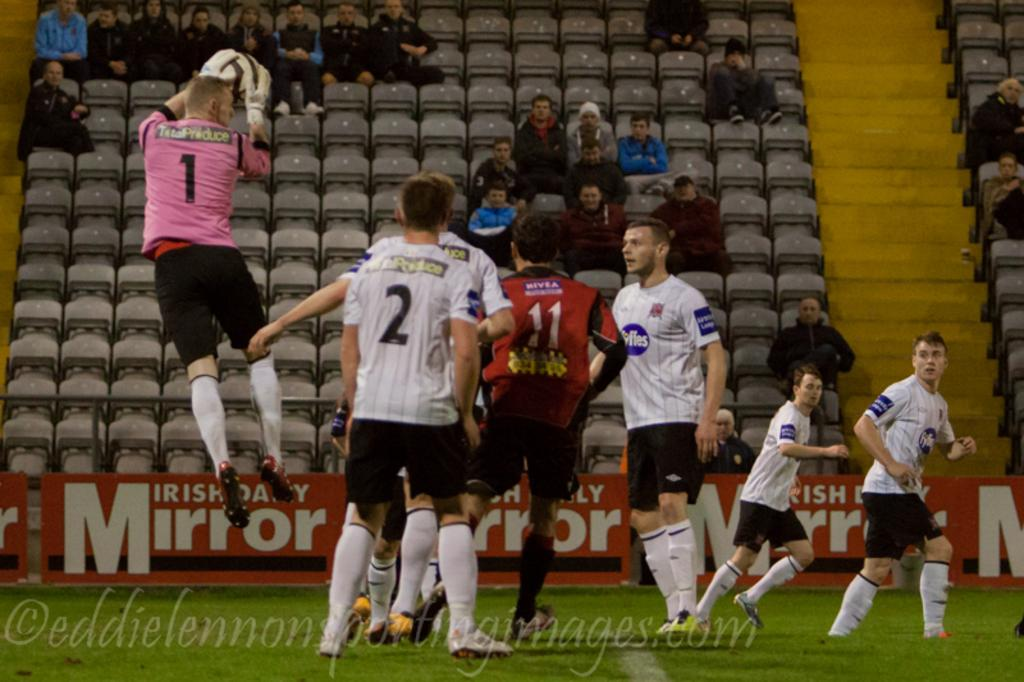<image>
Create a compact narrative representing the image presented. A number of soccer players play in a stadium with Irish Daily Mirror ads. 